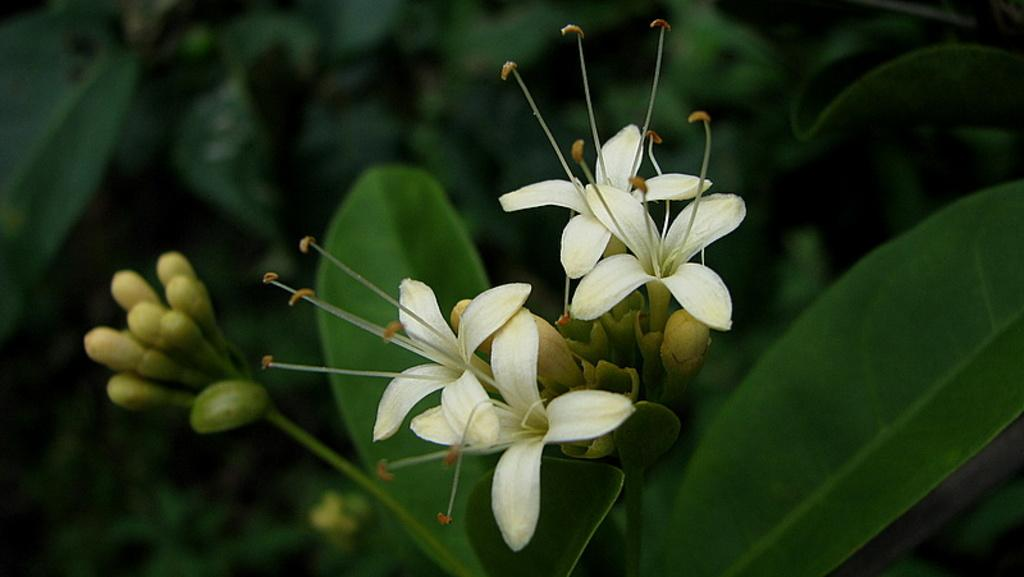What is the main subject in the center of the image? There is a plant in the center of the image. What are the characteristics of the plant? The plant has leaves and flowers in white color. What can be seen in the background of the image? There are planets and a few other objects visible in the background of the image. What knowledge can be gained from the plant's feet in the image? There are no feet present on the plant in the image, as plants do not have feet. 